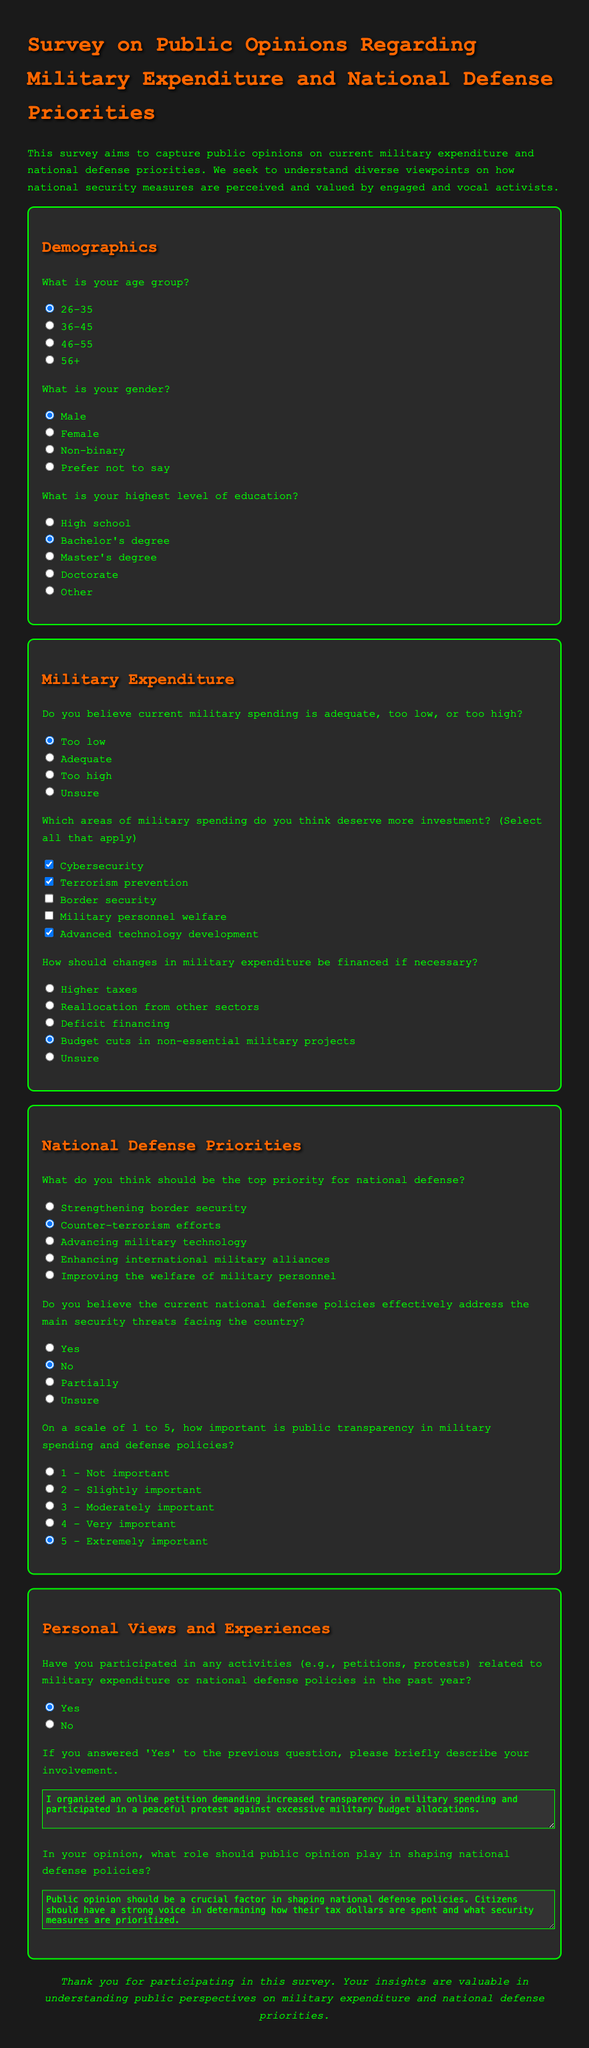What is the title of the survey? The title can be found in the header of the document, which states the purpose of the survey.
Answer: Survey on Public Opinions Regarding Military Expenditure and National Defense Priorities What age group is pre-selected in the survey? The pre-selected option is indicated with a checked radio button under the age group question.
Answer: 26-35 What is the highest level of education chosen by the respondent? The respondent's choice is indicated by the checked radio button for educational qualifications.
Answer: Bachelor's degree How many areas of military spending does the survey allow respondents to select? The survey includes a checkbox question that allows for multiple selections, specifying five areas for consideration.
Answer: Five What is the respondent's opinion on current national defense policies? The response is reflected by the checked radio button under the question regarding the effectiveness of defense policies.
Answer: No On a scale of 1 to 5, what importance does the survey assign to public transparency? The selected answer is identifiable by the checked radio button next to the importance scale question.
Answer: 5 - Extremely important What involvement did the respondent claim to have had in military expenditure-related activities? The answer is found in the text area response detailing past activities regarding military expenditure.
Answer: I organized an online petition demanding increased transparency in military spending and participated in a peaceful protest against excessive military budget allocations What role does the respondent believe public opinion should play in national defense policies? The response is given in the text area, reflecting the respondent's belief regarding public influence over defense policies.
Answer: Public opinion should be a crucial factor in shaping national defense policies. Citizens should have a strong voice in determining how their tax dollars are spent and what security measures are prioritized 